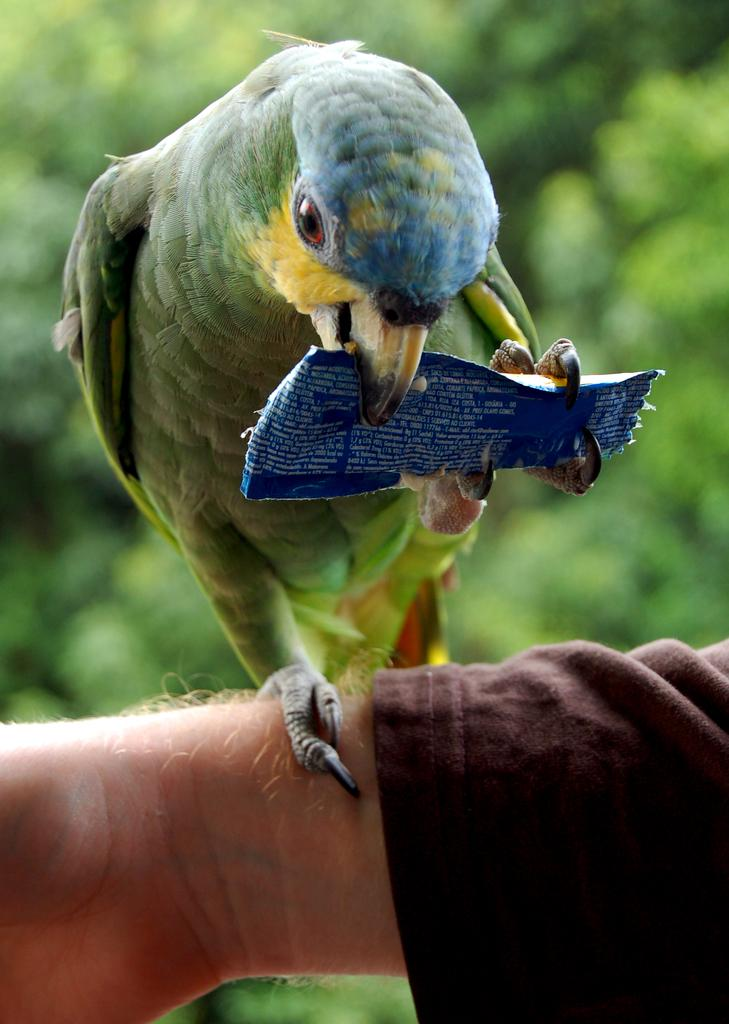What is being held in the person's hand in the image? There is a bird in the person's hand in the image. What is the bird doing in the image? The bird has an object in its mouth in the image. How would you describe the background of the image? The background of the image is blurred. What type of quill is the person using to write in the image? There is no quill present in the image; it features a person's hand holding a bird with an object in its mouth. Can you describe the art style of the image? The provided facts do not give enough information to determine the art style of the image. 